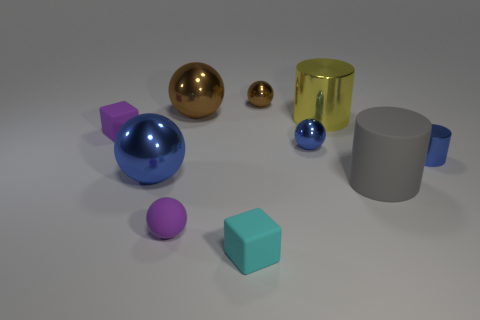Subtract all small shiny cylinders. How many cylinders are left? 2 Subtract all green cylinders. How many blue spheres are left? 2 Subtract all purple balls. How many balls are left? 4 Subtract 2 balls. How many balls are left? 3 Subtract all green balls. Subtract all cyan cylinders. How many balls are left? 5 Subtract all cubes. How many objects are left? 8 Subtract all gray rubber spheres. Subtract all small purple blocks. How many objects are left? 9 Add 2 metallic cylinders. How many metallic cylinders are left? 4 Add 4 big gray rubber cylinders. How many big gray rubber cylinders exist? 5 Subtract 1 purple blocks. How many objects are left? 9 